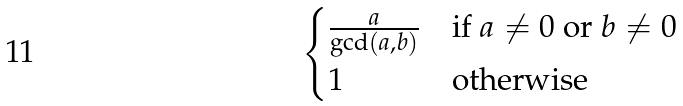<formula> <loc_0><loc_0><loc_500><loc_500>\begin{cases} \frac { a } { \gcd ( a , b ) } & \text {if $a\neq 0$ or $b\neq 0$} \\ 1 & \text {otherwise} \end{cases}</formula> 